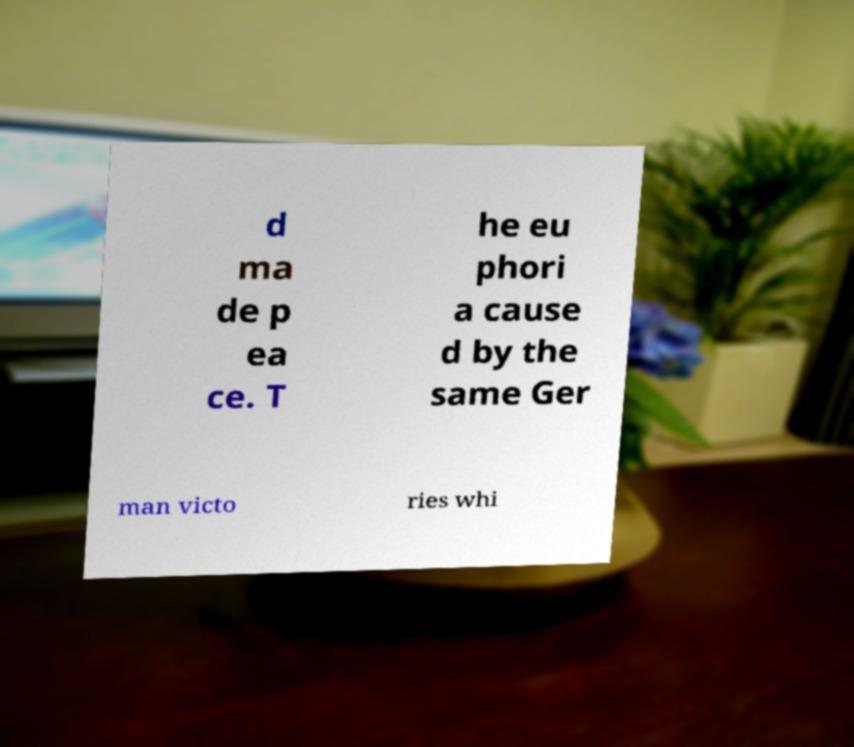Could you assist in decoding the text presented in this image and type it out clearly? d ma de p ea ce. T he eu phori a cause d by the same Ger man victo ries whi 